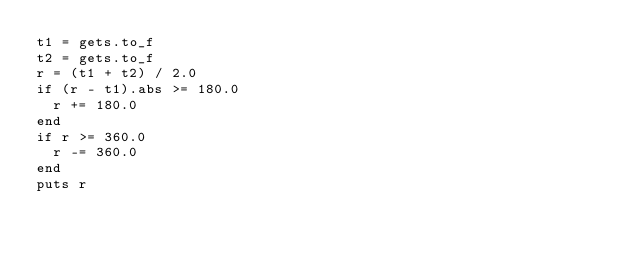<code> <loc_0><loc_0><loc_500><loc_500><_Ruby_>t1 = gets.to_f
t2 = gets.to_f
r = (t1 + t2) / 2.0
if (r - t1).abs >= 180.0
  r += 180.0
end
if r >= 360.0
  r -= 360.0
end
puts r</code> 